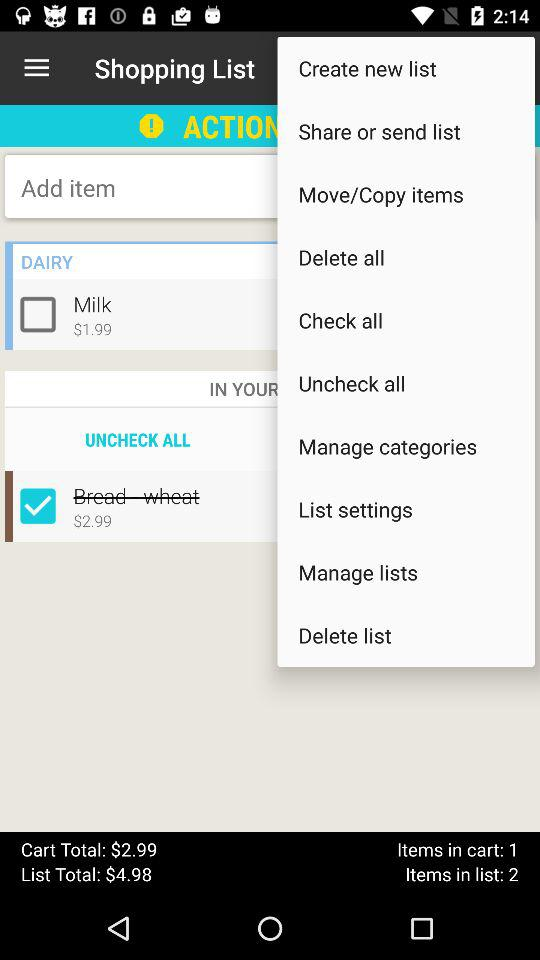What is the number of items in the list? The number of items in the list is 2. 